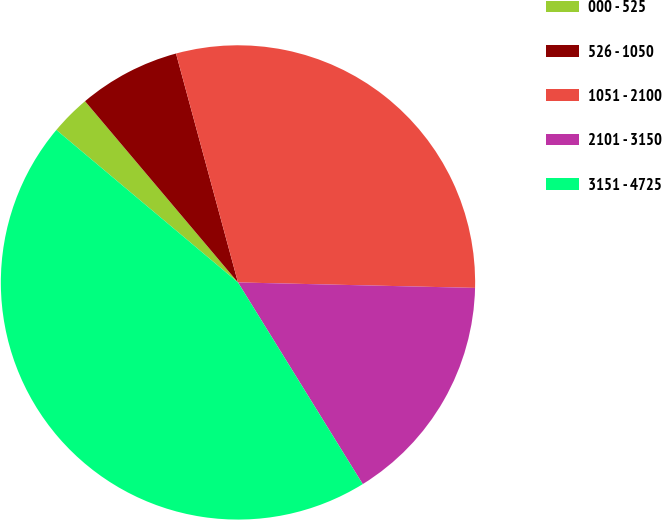Convert chart to OTSL. <chart><loc_0><loc_0><loc_500><loc_500><pie_chart><fcel>000 - 525<fcel>526 - 1050<fcel>1051 - 2100<fcel>2101 - 3150<fcel>3151 - 4725<nl><fcel>2.73%<fcel>6.95%<fcel>29.58%<fcel>15.82%<fcel>44.94%<nl></chart> 